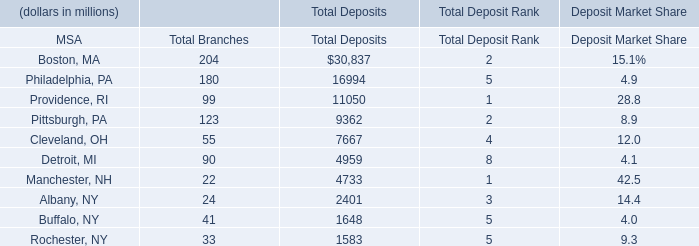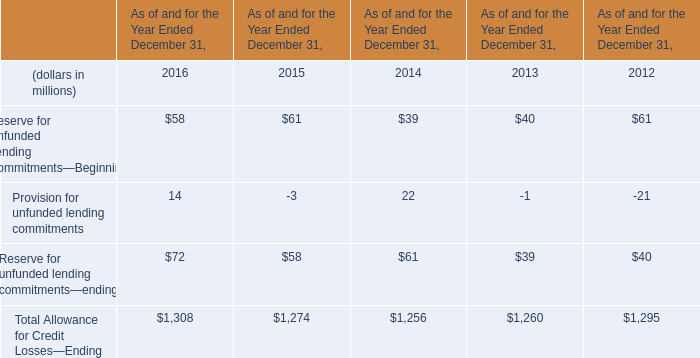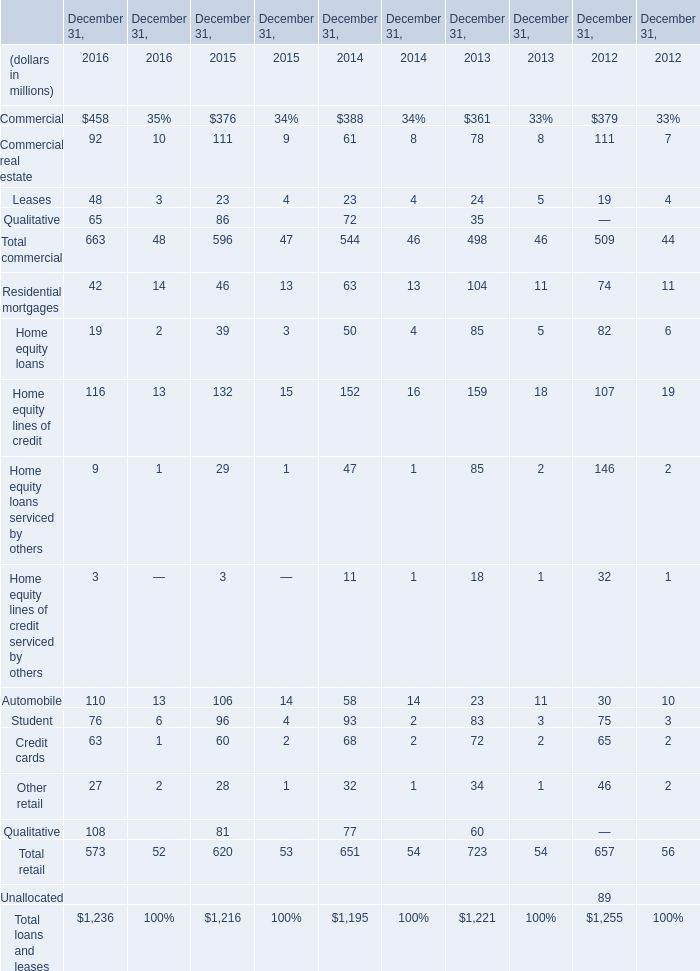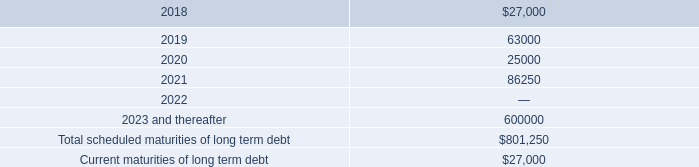Does Reserve for Unfunded Lending Commitments—Beginning keeps increasing each year between 2014 and 2016? 
Answer: no. 